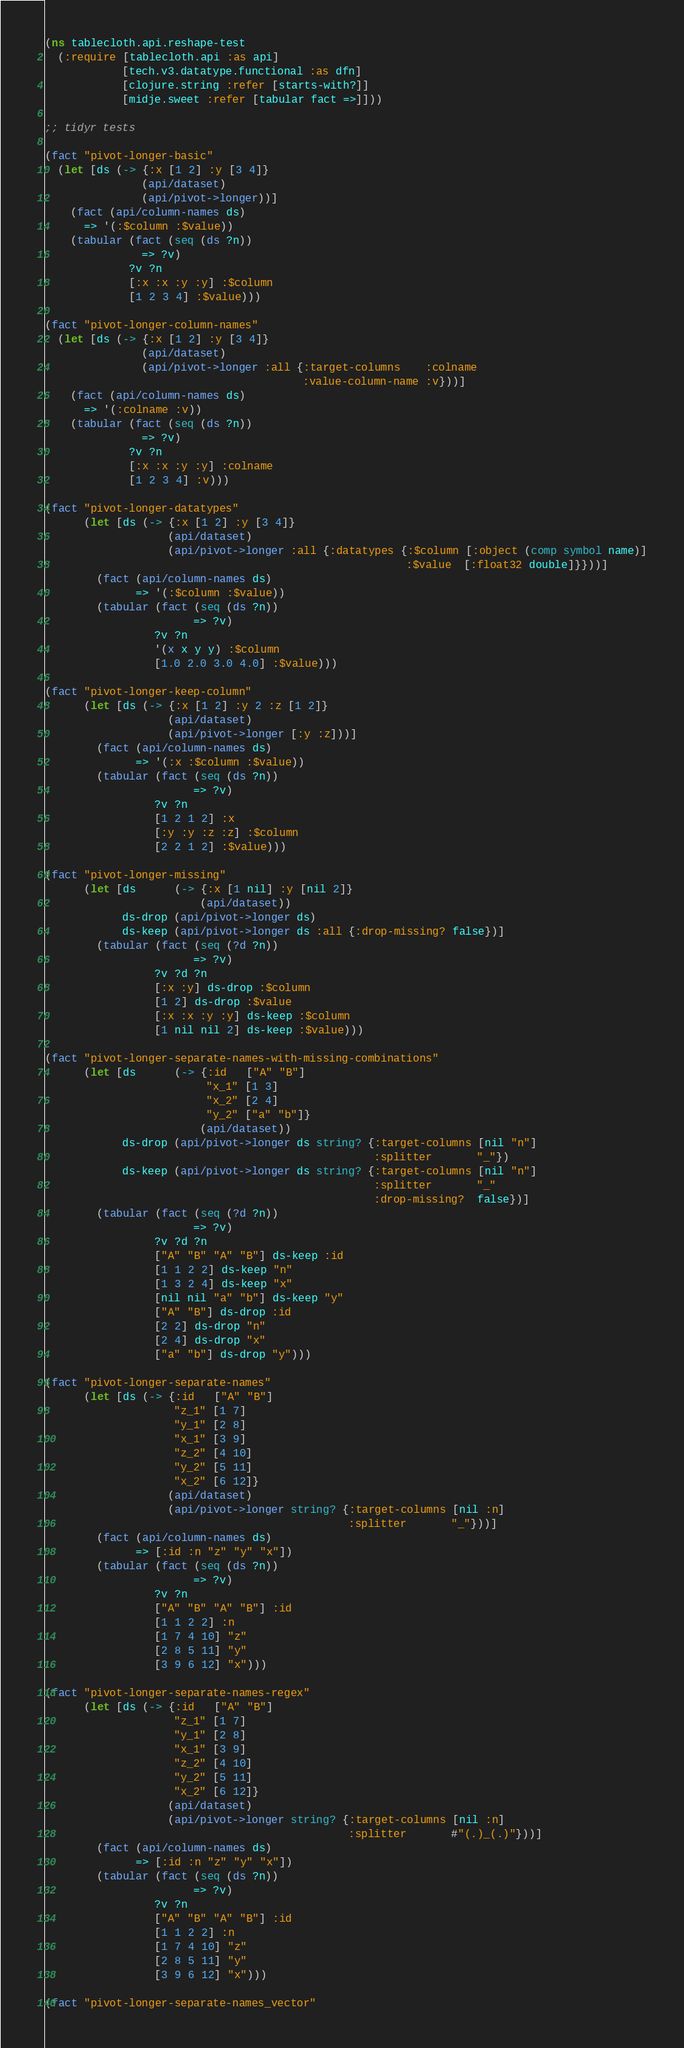<code> <loc_0><loc_0><loc_500><loc_500><_Clojure_>(ns tablecloth.api.reshape-test
  (:require [tablecloth.api :as api]
            [tech.v3.datatype.functional :as dfn]
            [clojure.string :refer [starts-with?]]
            [midje.sweet :refer [tabular fact =>]]))

;; tidyr tests

(fact "pivot-longer-basic"
  (let [ds (-> {:x [1 2] :y [3 4]}
               (api/dataset)
               (api/pivot->longer))]
    (fact (api/column-names ds)
      => '(:$column :$value))
    (tabular (fact (seq (ds ?n))
               => ?v)
             ?v ?n
             [:x :x :y :y] :$column
             [1 2 3 4] :$value)))

(fact "pivot-longer-column-names"
  (let [ds (-> {:x [1 2] :y [3 4]}
               (api/dataset)
               (api/pivot->longer :all {:target-columns    :colname
                                        :value-column-name :v}))]
    (fact (api/column-names ds)
      => '(:colname :v))
    (tabular (fact (seq (ds ?n))
               => ?v)
             ?v ?n
             [:x :x :y :y] :colname
             [1 2 3 4] :v)))

(fact "pivot-longer-datatypes"
      (let [ds (-> {:x [1 2] :y [3 4]}
                   (api/dataset)
                   (api/pivot->longer :all {:datatypes {:$column [:object (comp symbol name)]
                                                        :$value  [:float32 double]}}))]
        (fact (api/column-names ds)
              => '(:$column :$value))
        (tabular (fact (seq (ds ?n))
                       => ?v)
                 ?v ?n
                 '(x x y y) :$column
                 [1.0 2.0 3.0 4.0] :$value)))

(fact "pivot-longer-keep-column"
      (let [ds (-> {:x [1 2] :y 2 :z [1 2]}
                   (api/dataset)
                   (api/pivot->longer [:y :z]))]
        (fact (api/column-names ds)
              => '(:x :$column :$value))
        (tabular (fact (seq (ds ?n))
                       => ?v)
                 ?v ?n
                 [1 2 1 2] :x
                 [:y :y :z :z] :$column
                 [2 2 1 2] :$value)))

(fact "pivot-longer-missing"
      (let [ds      (-> {:x [1 nil] :y [nil 2]}
                        (api/dataset))
            ds-drop (api/pivot->longer ds)
            ds-keep (api/pivot->longer ds :all {:drop-missing? false})]
        (tabular (fact (seq (?d ?n))
                       => ?v)
                 ?v ?d ?n
                 [:x :y] ds-drop :$column
                 [1 2] ds-drop :$value
                 [:x :x :y :y] ds-keep :$column
                 [1 nil nil 2] ds-keep :$value)))

(fact "pivot-longer-separate-names-with-missing-combinations"
      (let [ds      (-> {:id   ["A" "B"]
                         "x_1" [1 3]
                         "x_2" [2 4]
                         "y_2" ["a" "b"]}
                        (api/dataset))
            ds-drop (api/pivot->longer ds string? {:target-columns [nil "n"]
                                                   :splitter       "_"})
            ds-keep (api/pivot->longer ds string? {:target-columns [nil "n"]
                                                   :splitter       "_"
                                                   :drop-missing?  false})]
        (tabular (fact (seq (?d ?n))
                       => ?v)
                 ?v ?d ?n
                 ["A" "B" "A" "B"] ds-keep :id
                 [1 1 2 2] ds-keep "n"
                 [1 3 2 4] ds-keep "x"
                 [nil nil "a" "b"] ds-keep "y"
                 ["A" "B"] ds-drop :id
                 [2 2] ds-drop "n"
                 [2 4] ds-drop "x"
                 ["a" "b"] ds-drop "y")))

(fact "pivot-longer-separate-names"
      (let [ds (-> {:id   ["A" "B"]
                    "z_1" [1 7]
                    "y_1" [2 8]
                    "x_1" [3 9]
                    "z_2" [4 10]
                    "y_2" [5 11]
                    "x_2" [6 12]}
                   (api/dataset)
                   (api/pivot->longer string? {:target-columns [nil :n]
                                               :splitter       "_"}))]
        (fact (api/column-names ds)
              => [:id :n "z" "y" "x"])
        (tabular (fact (seq (ds ?n))
                       => ?v)
                 ?v ?n
                 ["A" "B" "A" "B"] :id
                 [1 1 2 2] :n
                 [1 7 4 10] "z"
                 [2 8 5 11] "y"
                 [3 9 6 12] "x")))

(fact "pivot-longer-separate-names-regex"
      (let [ds (-> {:id   ["A" "B"]
                    "z_1" [1 7]
                    "y_1" [2 8]
                    "x_1" [3 9]
                    "z_2" [4 10]
                    "y_2" [5 11]
                    "x_2" [6 12]}
                   (api/dataset)
                   (api/pivot->longer string? {:target-columns [nil :n]
                                               :splitter       #"(.)_(.)"}))]
        (fact (api/column-names ds)
              => [:id :n "z" "y" "x"])
        (tabular (fact (seq (ds ?n))
                       => ?v)
                 ?v ?n
                 ["A" "B" "A" "B"] :id
                 [1 1 2 2] :n
                 [1 7 4 10] "z"
                 [2 8 5 11] "y"
                 [3 9 6 12] "x")))

(fact "pivot-longer-separate-names_vector"</code> 